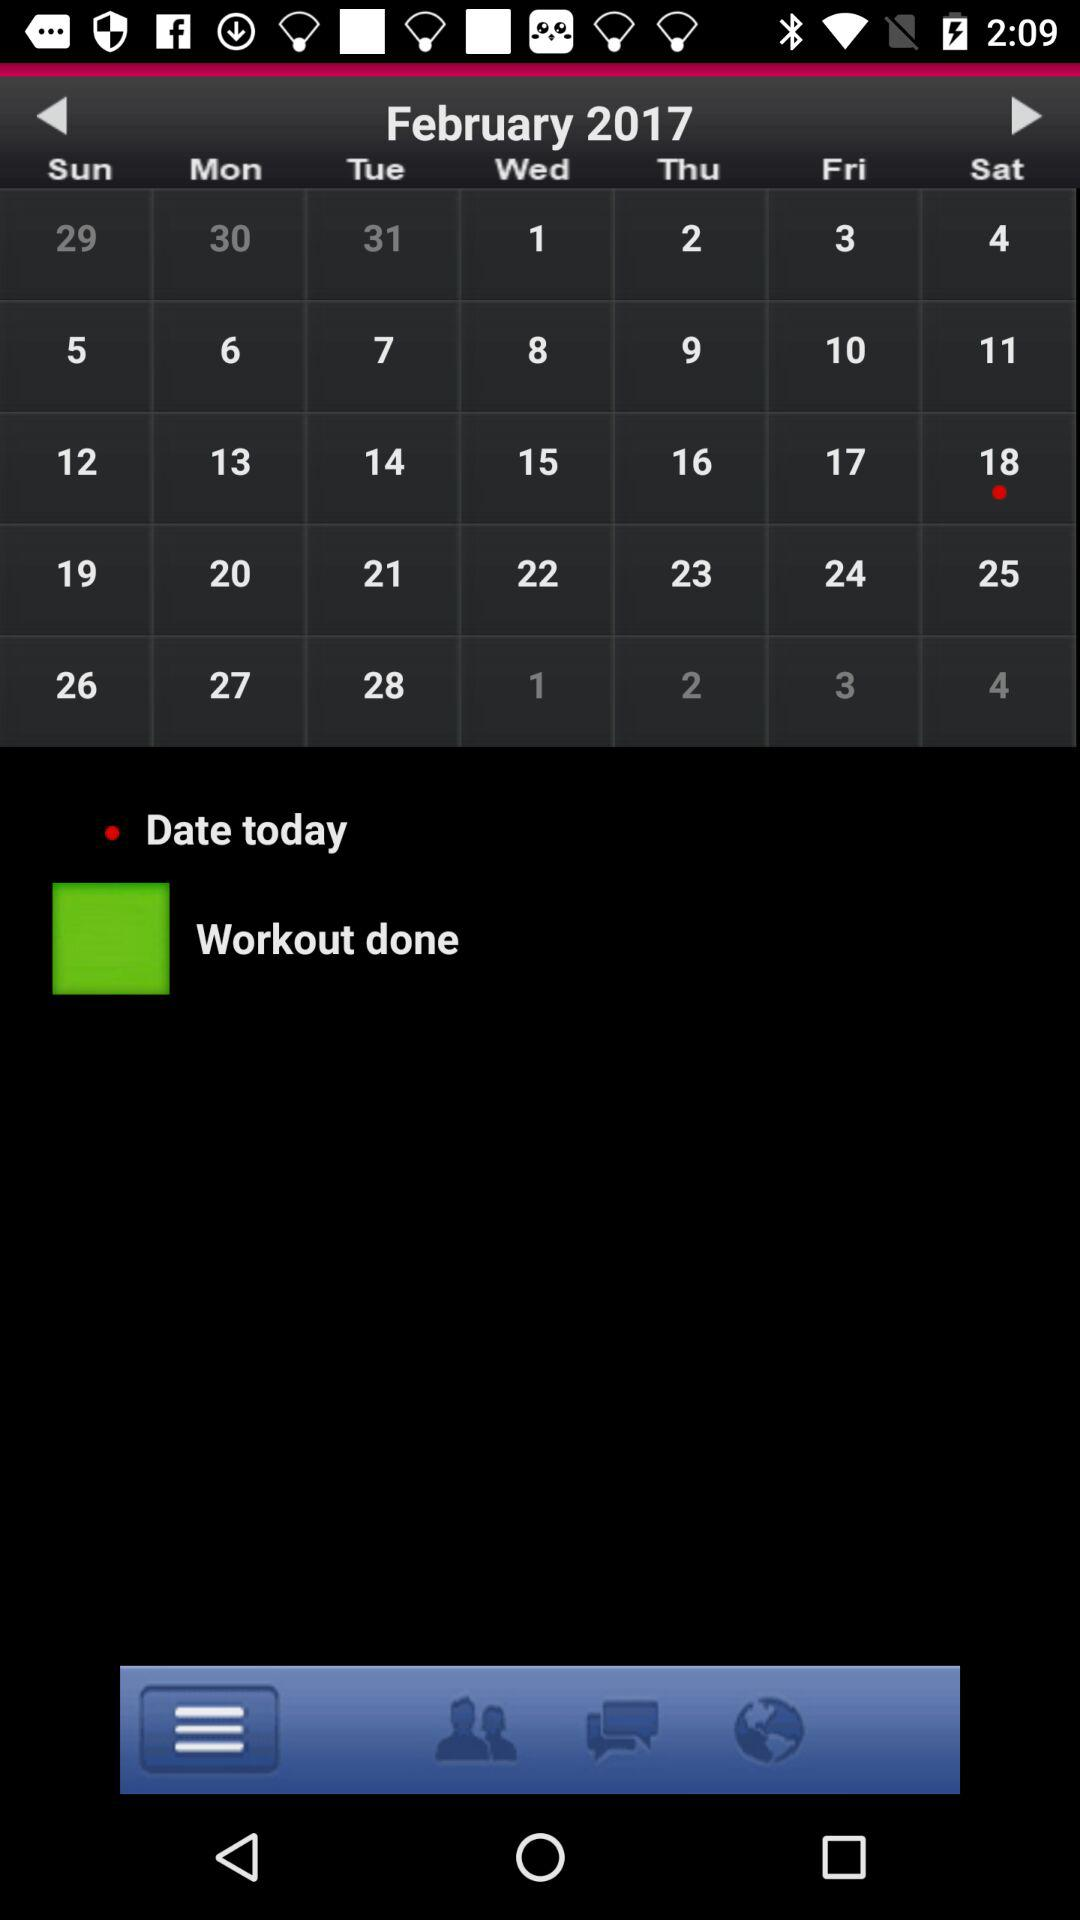Which month's calendar is it? The month is February. 